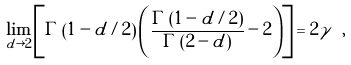Convert formula to latex. <formula><loc_0><loc_0><loc_500><loc_500>\lim _ { d \rightarrow 2 } \left [ \Gamma \left ( 1 - d / 2 \right ) \left ( \frac { \Gamma \left ( 1 - d / 2 \right ) } { \Gamma \left ( 2 - d \right ) } - 2 \right ) \right ] = 2 \gamma \ ,</formula> 